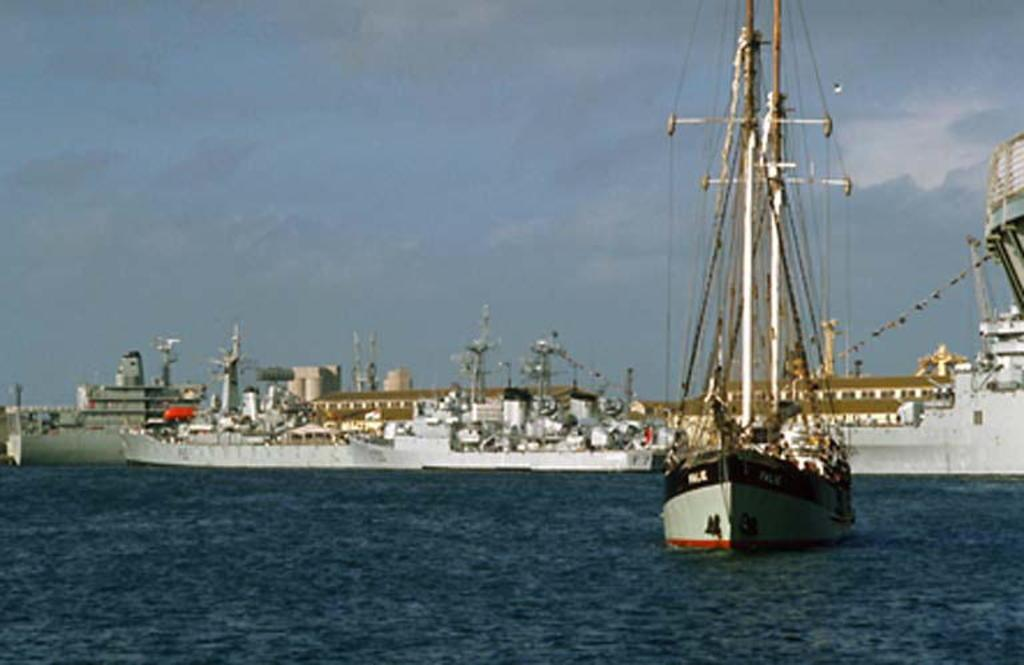What type of vehicle is present in the image? There is a boat in the image, and there are also ships. Where are the boat and ships located? The boat and ships are on the water. What can be seen in the background of the image? There are buildings and the sky visible in the background of the image. What is the condition of the sky in the image? The sky is visible in the background of the image, and there are clouds present. What type of thread is being used to connect the steam to the swing in the image? There is no steam, swing, or thread present in the image. 